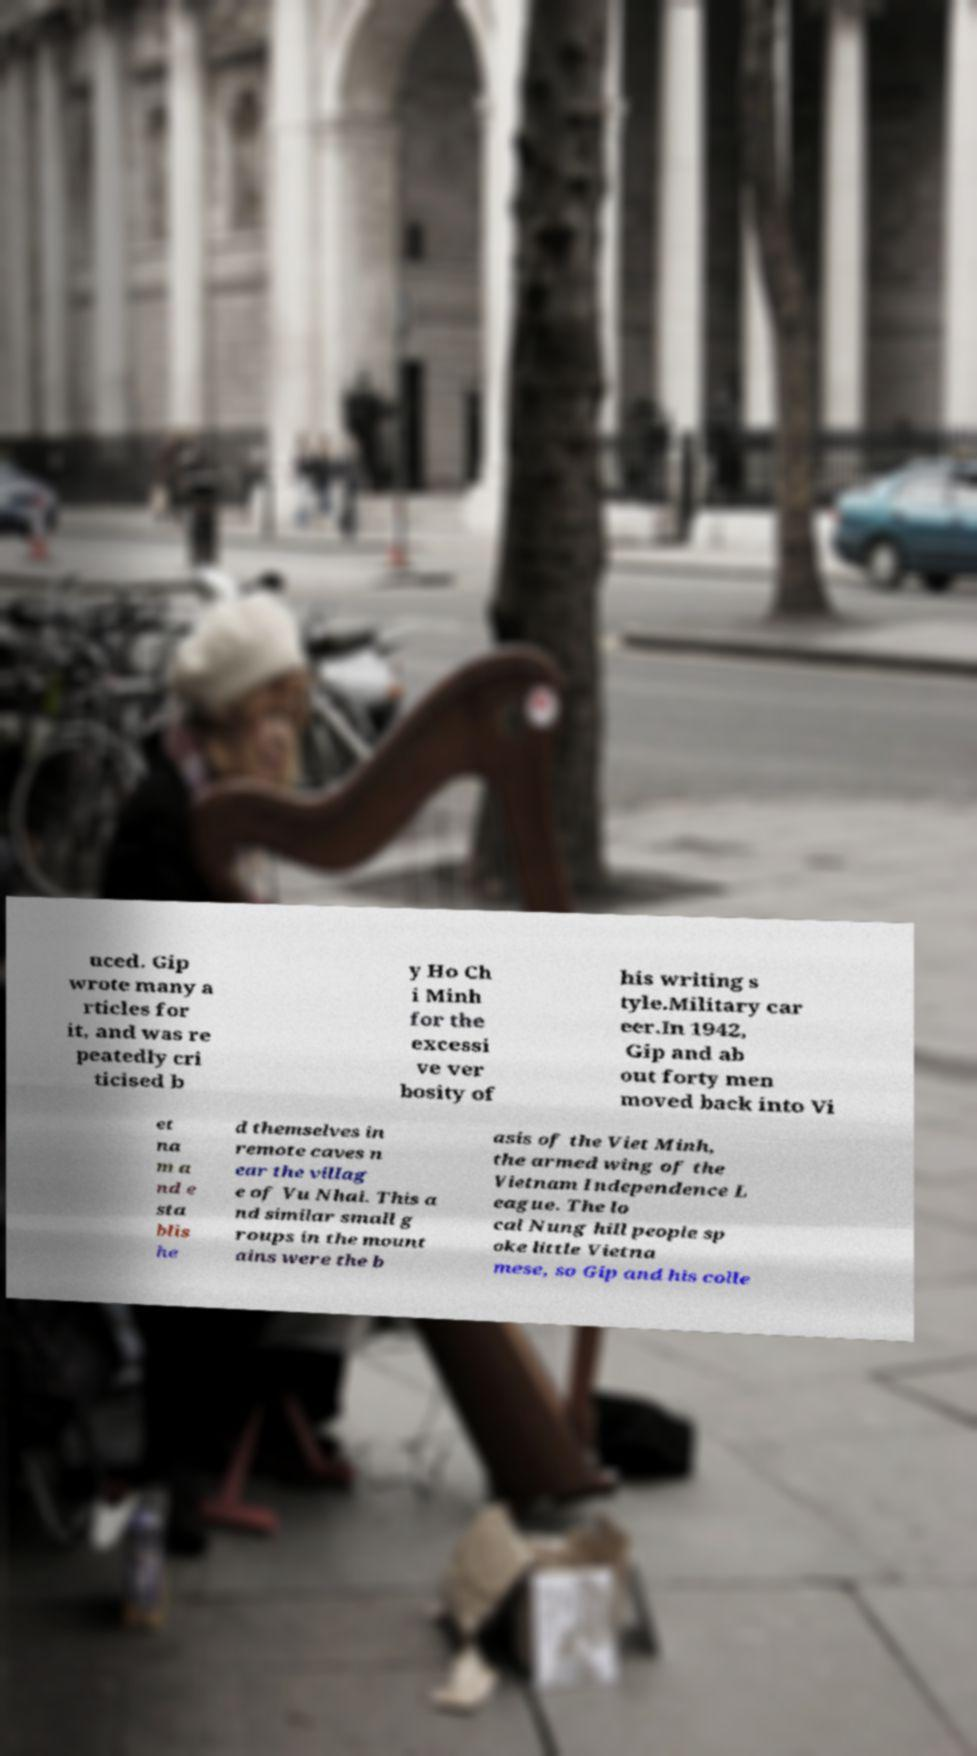Can you accurately transcribe the text from the provided image for me? uced. Gip wrote many a rticles for it, and was re peatedly cri ticised b y Ho Ch i Minh for the excessi ve ver bosity of his writing s tyle.Military car eer.In 1942, Gip and ab out forty men moved back into Vi et na m a nd e sta blis he d themselves in remote caves n ear the villag e of Vu Nhai. This a nd similar small g roups in the mount ains were the b asis of the Viet Minh, the armed wing of the Vietnam Independence L eague. The lo cal Nung hill people sp oke little Vietna mese, so Gip and his colle 